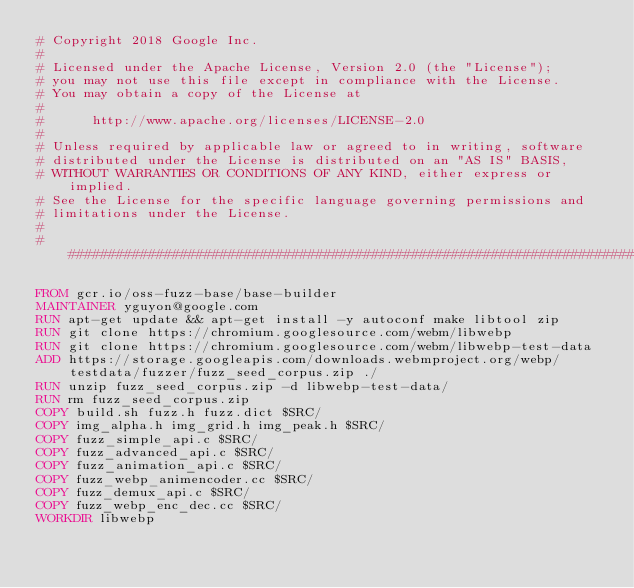<code> <loc_0><loc_0><loc_500><loc_500><_Dockerfile_># Copyright 2018 Google Inc.
#
# Licensed under the Apache License, Version 2.0 (the "License");
# you may not use this file except in compliance with the License.
# You may obtain a copy of the License at
#
#      http://www.apache.org/licenses/LICENSE-2.0
#
# Unless required by applicable law or agreed to in writing, software
# distributed under the License is distributed on an "AS IS" BASIS,
# WITHOUT WARRANTIES OR CONDITIONS OF ANY KIND, either express or implied.
# See the License for the specific language governing permissions and
# limitations under the License.
#
################################################################################

FROM gcr.io/oss-fuzz-base/base-builder
MAINTAINER yguyon@google.com
RUN apt-get update && apt-get install -y autoconf make libtool zip
RUN git clone https://chromium.googlesource.com/webm/libwebp
RUN git clone https://chromium.googlesource.com/webm/libwebp-test-data
ADD https://storage.googleapis.com/downloads.webmproject.org/webp/testdata/fuzzer/fuzz_seed_corpus.zip ./
RUN unzip fuzz_seed_corpus.zip -d libwebp-test-data/
RUN rm fuzz_seed_corpus.zip
COPY build.sh fuzz.h fuzz.dict $SRC/
COPY img_alpha.h img_grid.h img_peak.h $SRC/
COPY fuzz_simple_api.c $SRC/
COPY fuzz_advanced_api.c $SRC/
COPY fuzz_animation_api.c $SRC/
COPY fuzz_webp_animencoder.cc $SRC/
COPY fuzz_demux_api.c $SRC/
COPY fuzz_webp_enc_dec.cc $SRC/
WORKDIR libwebp
</code> 